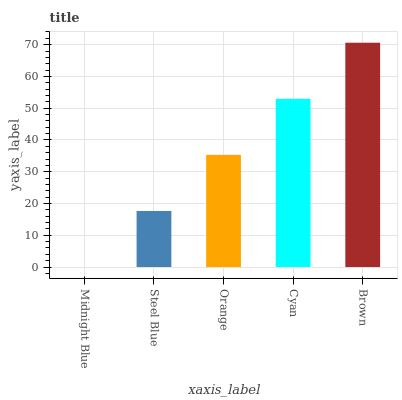Is Midnight Blue the minimum?
Answer yes or no. Yes. Is Brown the maximum?
Answer yes or no. Yes. Is Steel Blue the minimum?
Answer yes or no. No. Is Steel Blue the maximum?
Answer yes or no. No. Is Steel Blue greater than Midnight Blue?
Answer yes or no. Yes. Is Midnight Blue less than Steel Blue?
Answer yes or no. Yes. Is Midnight Blue greater than Steel Blue?
Answer yes or no. No. Is Steel Blue less than Midnight Blue?
Answer yes or no. No. Is Orange the high median?
Answer yes or no. Yes. Is Orange the low median?
Answer yes or no. Yes. Is Brown the high median?
Answer yes or no. No. Is Cyan the low median?
Answer yes or no. No. 